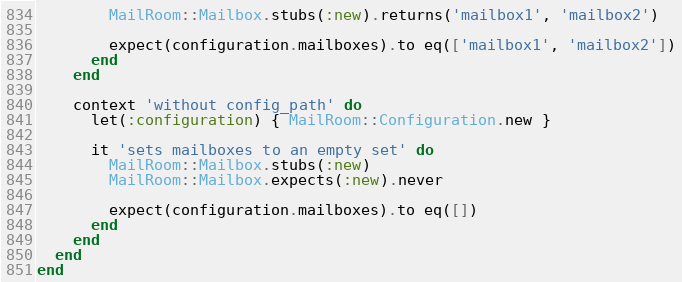Convert code to text. <code><loc_0><loc_0><loc_500><loc_500><_Ruby_>        MailRoom::Mailbox.stubs(:new).returns('mailbox1', 'mailbox2')

        expect(configuration.mailboxes).to eq(['mailbox1', 'mailbox2'])
      end
    end

    context 'without config_path' do
      let(:configuration) { MailRoom::Configuration.new }

      it 'sets mailboxes to an empty set' do
        MailRoom::Mailbox.stubs(:new)
        MailRoom::Mailbox.expects(:new).never

        expect(configuration.mailboxes).to eq([])
      end
    end
  end
end
</code> 